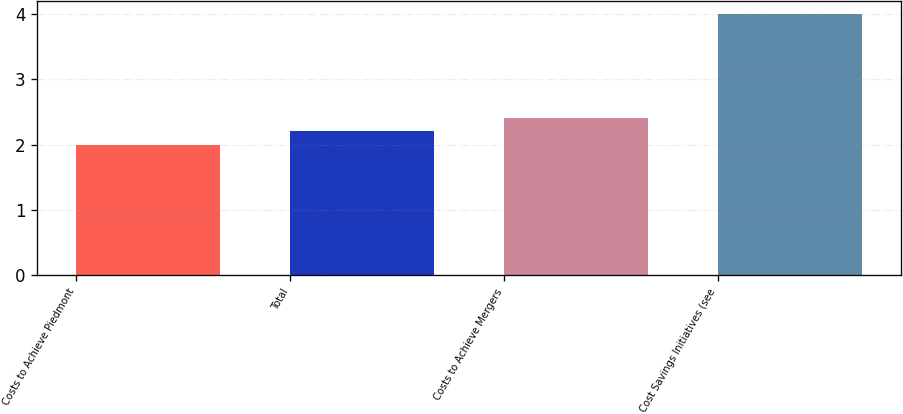Convert chart. <chart><loc_0><loc_0><loc_500><loc_500><bar_chart><fcel>Costs to Achieve Piedmont<fcel>Total<fcel>Costs to Achieve Mergers<fcel>Cost Savings Initiatives (see<nl><fcel>2<fcel>2.2<fcel>2.4<fcel>4<nl></chart> 